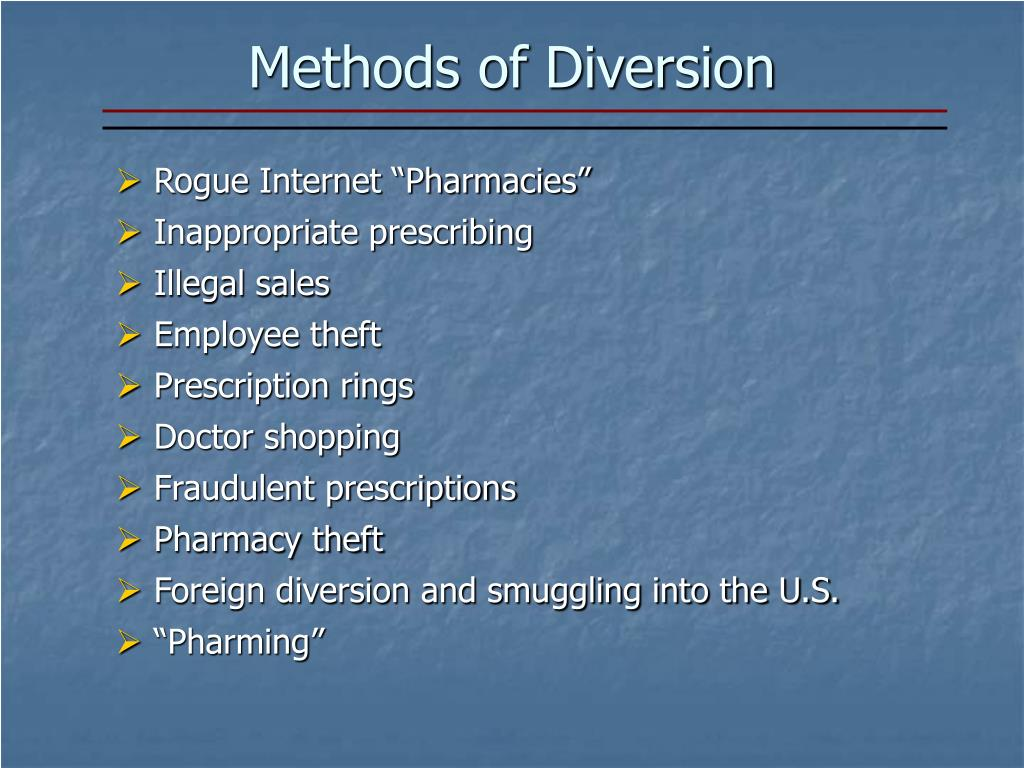What are some potential legal and regulatory issues that complicate tracking 'Foreign diversion and smuggling into the U.S.'? Tracking 'Foreign diversion and smuggling into the U.S.' involves several legal and regulatory challenges. Firstly, differences in national laws can create enforcement gaps where certain actions are illegal in one country but not another. Additionally, international smuggling networks often exploit these legal discrepancies. Jurisdictional limitations also impede law enforcement, as agencies from different countries may have limited authority to act beyond their borders. Furthermore, achieving timely and effective international cooperation can be challenging due to varying bureaucratic processes, resource constraints, and political issues. Combating such smuggling also requires extensive resources for monitoring and intelligence-sharing, which can be difficult to maintain consistently across borders. 